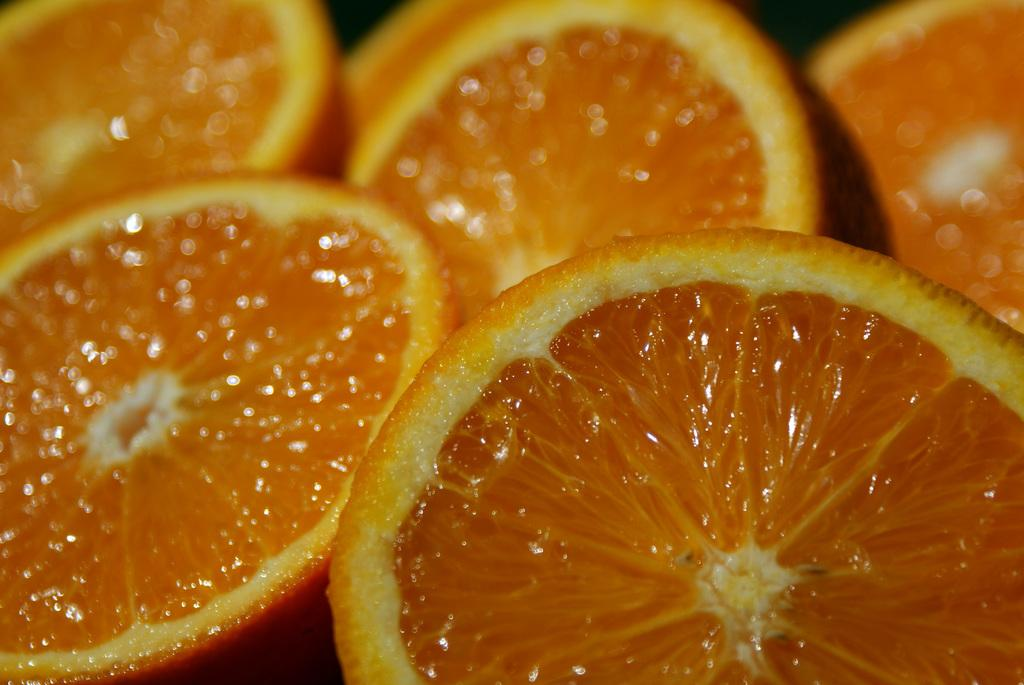What type of food can be seen in the image? There are fruits in the image. What is the color of the fruits? The fruits are in orange color. What type of bomb is present in the image? There is no bomb present in the image; it features fruits in orange color. What type of badge can be seen on the secretary in the image? There is no secretary or badge present in the image; it only features fruits in orange color. 